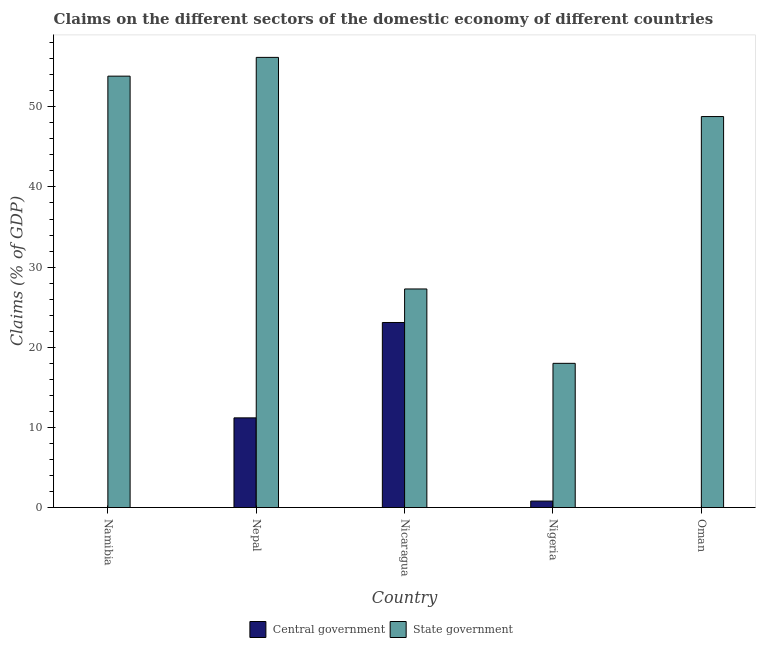How many different coloured bars are there?
Offer a very short reply. 2. Are the number of bars per tick equal to the number of legend labels?
Make the answer very short. No. Are the number of bars on each tick of the X-axis equal?
Your response must be concise. No. How many bars are there on the 5th tick from the left?
Keep it short and to the point. 1. What is the label of the 1st group of bars from the left?
Ensure brevity in your answer.  Namibia. In how many cases, is the number of bars for a given country not equal to the number of legend labels?
Offer a very short reply. 2. What is the claims on central government in Nepal?
Offer a terse response. 11.19. Across all countries, what is the maximum claims on central government?
Provide a short and direct response. 23.09. Across all countries, what is the minimum claims on state government?
Give a very brief answer. 17.99. In which country was the claims on central government maximum?
Give a very brief answer. Nicaragua. What is the total claims on state government in the graph?
Offer a very short reply. 204.04. What is the difference between the claims on state government in Nicaragua and that in Nigeria?
Your response must be concise. 9.28. What is the difference between the claims on state government in Nepal and the claims on central government in Namibia?
Provide a succinct answer. 56.17. What is the average claims on state government per country?
Make the answer very short. 40.81. What is the difference between the claims on state government and claims on central government in Nigeria?
Provide a short and direct response. 17.19. What is the ratio of the claims on state government in Nicaragua to that in Nigeria?
Offer a terse response. 1.52. Is the difference between the claims on central government in Nepal and Nigeria greater than the difference between the claims on state government in Nepal and Nigeria?
Provide a succinct answer. No. What is the difference between the highest and the second highest claims on state government?
Ensure brevity in your answer.  2.34. What is the difference between the highest and the lowest claims on state government?
Offer a terse response. 38.17. How many bars are there?
Keep it short and to the point. 8. Are all the bars in the graph horizontal?
Provide a succinct answer. No. What is the difference between two consecutive major ticks on the Y-axis?
Keep it short and to the point. 10. Does the graph contain any zero values?
Provide a short and direct response. Yes. What is the title of the graph?
Keep it short and to the point. Claims on the different sectors of the domestic economy of different countries. What is the label or title of the Y-axis?
Offer a very short reply. Claims (% of GDP). What is the Claims (% of GDP) in State government in Namibia?
Your response must be concise. 53.82. What is the Claims (% of GDP) of Central government in Nepal?
Give a very brief answer. 11.19. What is the Claims (% of GDP) in State government in Nepal?
Your response must be concise. 56.17. What is the Claims (% of GDP) in Central government in Nicaragua?
Your answer should be compact. 23.09. What is the Claims (% of GDP) of State government in Nicaragua?
Give a very brief answer. 27.27. What is the Claims (% of GDP) in Central government in Nigeria?
Provide a succinct answer. 0.81. What is the Claims (% of GDP) in State government in Nigeria?
Give a very brief answer. 17.99. What is the Claims (% of GDP) of State government in Oman?
Offer a very short reply. 48.78. Across all countries, what is the maximum Claims (% of GDP) of Central government?
Offer a terse response. 23.09. Across all countries, what is the maximum Claims (% of GDP) of State government?
Your response must be concise. 56.17. Across all countries, what is the minimum Claims (% of GDP) of State government?
Your answer should be very brief. 17.99. What is the total Claims (% of GDP) in Central government in the graph?
Provide a short and direct response. 35.08. What is the total Claims (% of GDP) in State government in the graph?
Offer a terse response. 204.04. What is the difference between the Claims (% of GDP) in State government in Namibia and that in Nepal?
Your answer should be very brief. -2.34. What is the difference between the Claims (% of GDP) of State government in Namibia and that in Nicaragua?
Make the answer very short. 26.55. What is the difference between the Claims (% of GDP) of State government in Namibia and that in Nigeria?
Ensure brevity in your answer.  35.83. What is the difference between the Claims (% of GDP) of State government in Namibia and that in Oman?
Offer a very short reply. 5.04. What is the difference between the Claims (% of GDP) in Central government in Nepal and that in Nicaragua?
Offer a very short reply. -11.9. What is the difference between the Claims (% of GDP) in State government in Nepal and that in Nicaragua?
Your answer should be compact. 28.9. What is the difference between the Claims (% of GDP) of Central government in Nepal and that in Nigeria?
Your answer should be very brief. 10.38. What is the difference between the Claims (% of GDP) of State government in Nepal and that in Nigeria?
Ensure brevity in your answer.  38.17. What is the difference between the Claims (% of GDP) in State government in Nepal and that in Oman?
Make the answer very short. 7.38. What is the difference between the Claims (% of GDP) of Central government in Nicaragua and that in Nigeria?
Ensure brevity in your answer.  22.28. What is the difference between the Claims (% of GDP) of State government in Nicaragua and that in Nigeria?
Ensure brevity in your answer.  9.28. What is the difference between the Claims (% of GDP) of State government in Nicaragua and that in Oman?
Offer a very short reply. -21.51. What is the difference between the Claims (% of GDP) of State government in Nigeria and that in Oman?
Make the answer very short. -30.79. What is the difference between the Claims (% of GDP) in Central government in Nepal and the Claims (% of GDP) in State government in Nicaragua?
Your answer should be compact. -16.08. What is the difference between the Claims (% of GDP) of Central government in Nepal and the Claims (% of GDP) of State government in Nigeria?
Offer a terse response. -6.8. What is the difference between the Claims (% of GDP) in Central government in Nepal and the Claims (% of GDP) in State government in Oman?
Offer a very short reply. -37.59. What is the difference between the Claims (% of GDP) in Central government in Nicaragua and the Claims (% of GDP) in State government in Nigeria?
Provide a short and direct response. 5.09. What is the difference between the Claims (% of GDP) of Central government in Nicaragua and the Claims (% of GDP) of State government in Oman?
Make the answer very short. -25.7. What is the difference between the Claims (% of GDP) of Central government in Nigeria and the Claims (% of GDP) of State government in Oman?
Ensure brevity in your answer.  -47.98. What is the average Claims (% of GDP) of Central government per country?
Ensure brevity in your answer.  7.02. What is the average Claims (% of GDP) in State government per country?
Your answer should be compact. 40.81. What is the difference between the Claims (% of GDP) of Central government and Claims (% of GDP) of State government in Nepal?
Ensure brevity in your answer.  -44.98. What is the difference between the Claims (% of GDP) of Central government and Claims (% of GDP) of State government in Nicaragua?
Offer a very short reply. -4.18. What is the difference between the Claims (% of GDP) in Central government and Claims (% of GDP) in State government in Nigeria?
Keep it short and to the point. -17.19. What is the ratio of the Claims (% of GDP) of State government in Namibia to that in Nepal?
Your response must be concise. 0.96. What is the ratio of the Claims (% of GDP) of State government in Namibia to that in Nicaragua?
Keep it short and to the point. 1.97. What is the ratio of the Claims (% of GDP) of State government in Namibia to that in Nigeria?
Offer a very short reply. 2.99. What is the ratio of the Claims (% of GDP) in State government in Namibia to that in Oman?
Your answer should be very brief. 1.1. What is the ratio of the Claims (% of GDP) of Central government in Nepal to that in Nicaragua?
Your answer should be compact. 0.48. What is the ratio of the Claims (% of GDP) of State government in Nepal to that in Nicaragua?
Offer a terse response. 2.06. What is the ratio of the Claims (% of GDP) in Central government in Nepal to that in Nigeria?
Offer a very short reply. 13.89. What is the ratio of the Claims (% of GDP) in State government in Nepal to that in Nigeria?
Offer a very short reply. 3.12. What is the ratio of the Claims (% of GDP) of State government in Nepal to that in Oman?
Your response must be concise. 1.15. What is the ratio of the Claims (% of GDP) in Central government in Nicaragua to that in Nigeria?
Make the answer very short. 28.66. What is the ratio of the Claims (% of GDP) of State government in Nicaragua to that in Nigeria?
Provide a succinct answer. 1.52. What is the ratio of the Claims (% of GDP) of State government in Nicaragua to that in Oman?
Your response must be concise. 0.56. What is the ratio of the Claims (% of GDP) of State government in Nigeria to that in Oman?
Your answer should be compact. 0.37. What is the difference between the highest and the second highest Claims (% of GDP) in Central government?
Ensure brevity in your answer.  11.9. What is the difference between the highest and the second highest Claims (% of GDP) in State government?
Provide a succinct answer. 2.34. What is the difference between the highest and the lowest Claims (% of GDP) in Central government?
Make the answer very short. 23.09. What is the difference between the highest and the lowest Claims (% of GDP) of State government?
Keep it short and to the point. 38.17. 